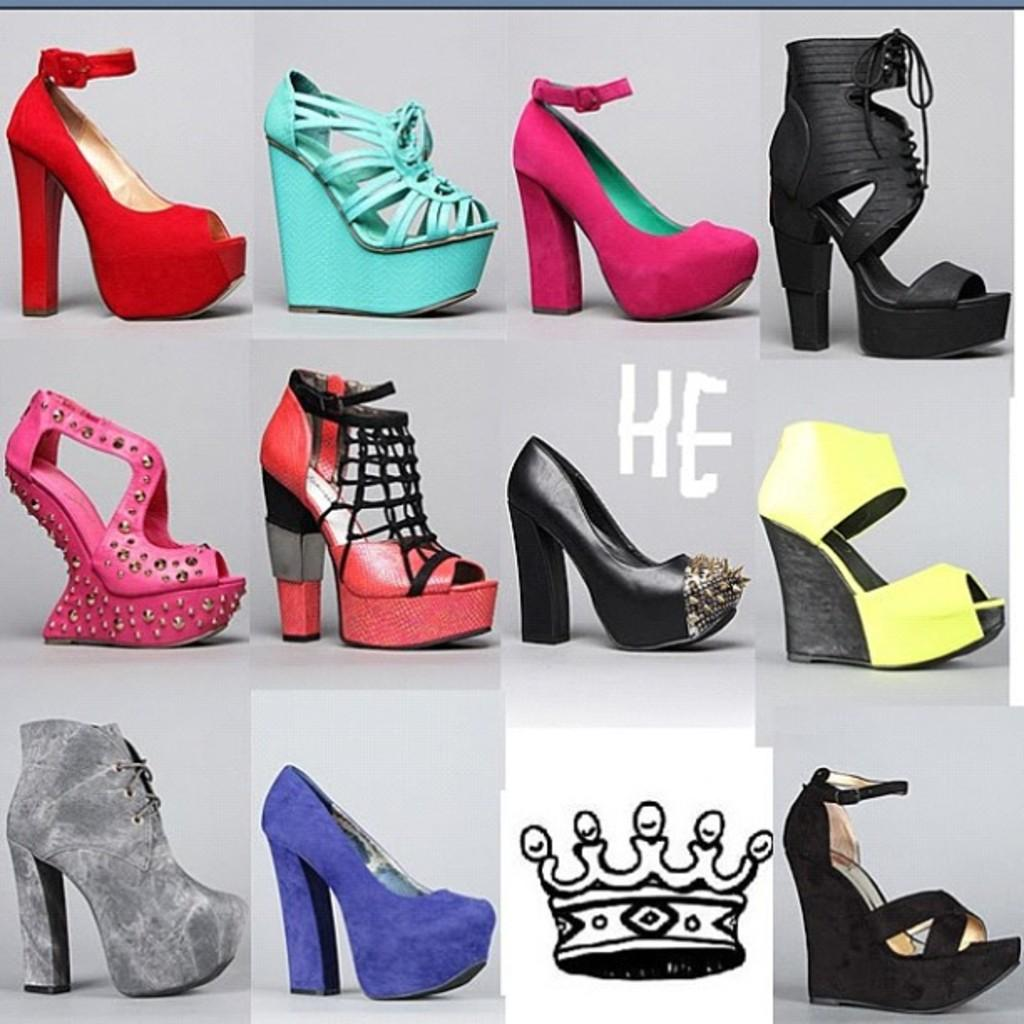What type of footwear is featured in the image? There are different models of sandals in the image. Can you describe any other elements in the image besides the sandals? Yes, there is an image of a crown visible in the image. What type of oven is used to bake the sandals in the image? There is no oven present in the image, and sandals are not baked; they are a type of footwear. 